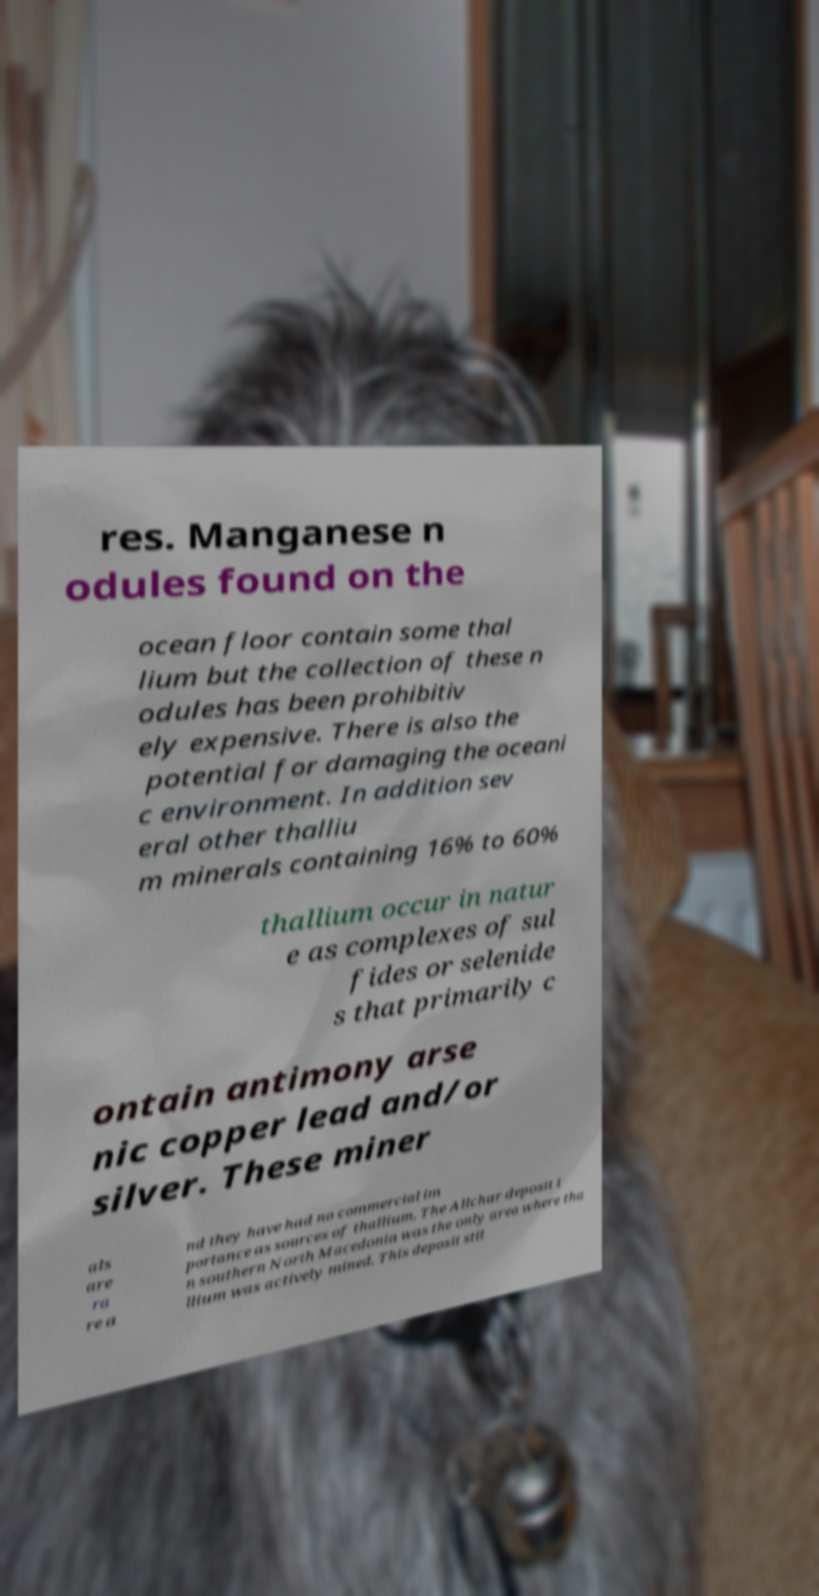Could you extract and type out the text from this image? res. Manganese n odules found on the ocean floor contain some thal lium but the collection of these n odules has been prohibitiv ely expensive. There is also the potential for damaging the oceani c environment. In addition sev eral other thalliu m minerals containing 16% to 60% thallium occur in natur e as complexes of sul fides or selenide s that primarily c ontain antimony arse nic copper lead and/or silver. These miner als are ra re a nd they have had no commercial im portance as sources of thallium. The Allchar deposit i n southern North Macedonia was the only area where tha llium was actively mined. This deposit stil 